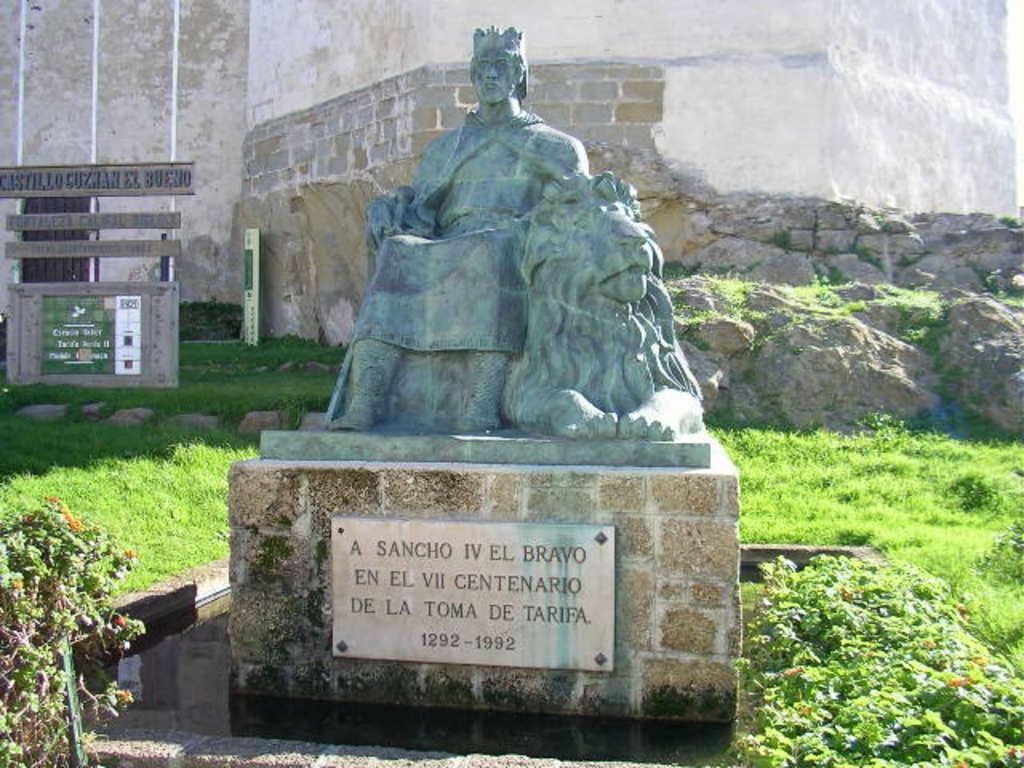How would you summarize this image in a sentence or two? In front of the image there is a statue on a concrete platform with some text engraved on it, around the statue there are flowers, plants and grass and there is water, behind the statue there is a rock, on top of the rock there is a building, in front of the building there are name boards. 